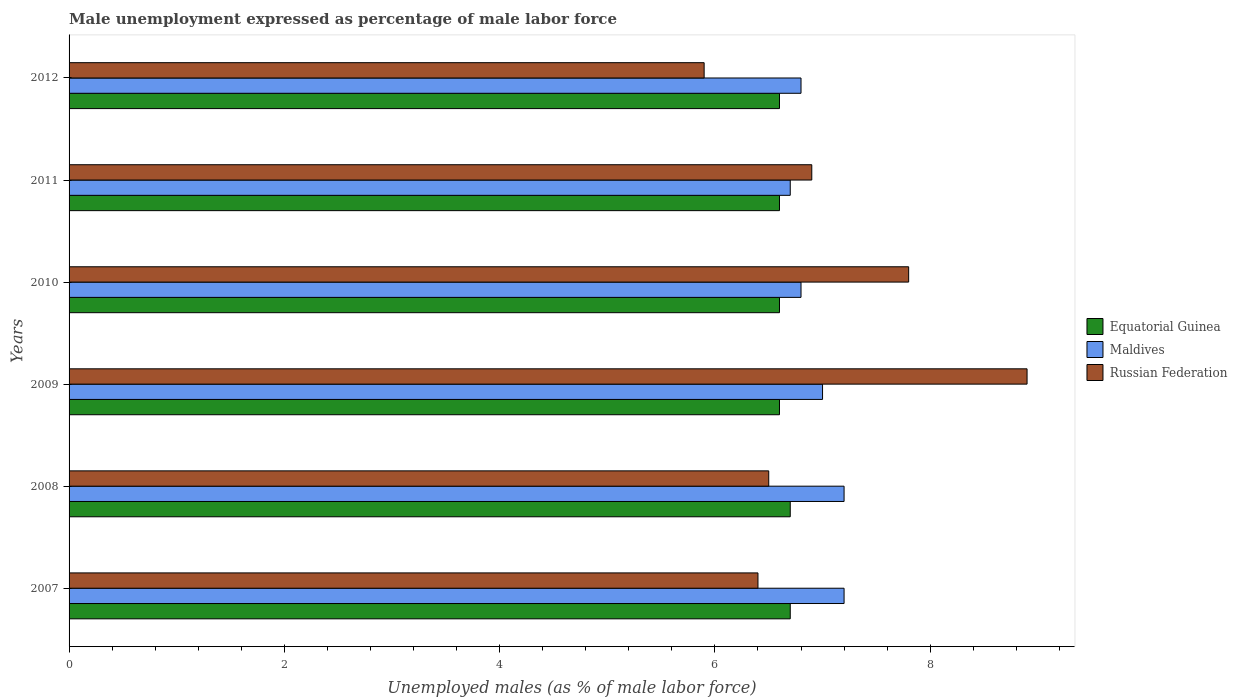How many different coloured bars are there?
Ensure brevity in your answer.  3. How many groups of bars are there?
Your answer should be compact. 6. Are the number of bars per tick equal to the number of legend labels?
Offer a very short reply. Yes. Are the number of bars on each tick of the Y-axis equal?
Give a very brief answer. Yes. How many bars are there on the 1st tick from the bottom?
Give a very brief answer. 3. What is the label of the 5th group of bars from the top?
Provide a succinct answer. 2008. In how many cases, is the number of bars for a given year not equal to the number of legend labels?
Keep it short and to the point. 0. What is the unemployment in males in in Equatorial Guinea in 2007?
Ensure brevity in your answer.  6.7. Across all years, what is the maximum unemployment in males in in Equatorial Guinea?
Offer a terse response. 6.7. Across all years, what is the minimum unemployment in males in in Equatorial Guinea?
Your answer should be compact. 6.6. In which year was the unemployment in males in in Russian Federation minimum?
Your answer should be compact. 2012. What is the total unemployment in males in in Equatorial Guinea in the graph?
Your response must be concise. 39.8. What is the difference between the unemployment in males in in Equatorial Guinea in 2010 and that in 2011?
Offer a very short reply. 0. What is the difference between the unemployment in males in in Russian Federation in 2009 and the unemployment in males in in Maldives in 2012?
Make the answer very short. 2.1. What is the average unemployment in males in in Russian Federation per year?
Your answer should be compact. 7.07. In the year 2008, what is the difference between the unemployment in males in in Russian Federation and unemployment in males in in Equatorial Guinea?
Offer a very short reply. -0.2. In how many years, is the unemployment in males in in Russian Federation greater than 2.8 %?
Make the answer very short. 6. What is the ratio of the unemployment in males in in Equatorial Guinea in 2007 to that in 2012?
Offer a very short reply. 1.02. Is the unemployment in males in in Russian Federation in 2010 less than that in 2012?
Offer a terse response. No. What is the difference between the highest and the lowest unemployment in males in in Russian Federation?
Give a very brief answer. 3. In how many years, is the unemployment in males in in Russian Federation greater than the average unemployment in males in in Russian Federation taken over all years?
Your answer should be compact. 2. What does the 3rd bar from the top in 2010 represents?
Make the answer very short. Equatorial Guinea. What does the 2nd bar from the bottom in 2011 represents?
Provide a short and direct response. Maldives. Is it the case that in every year, the sum of the unemployment in males in in Russian Federation and unemployment in males in in Maldives is greater than the unemployment in males in in Equatorial Guinea?
Your answer should be compact. Yes. How many bars are there?
Offer a terse response. 18. What is the difference between two consecutive major ticks on the X-axis?
Keep it short and to the point. 2. Are the values on the major ticks of X-axis written in scientific E-notation?
Your response must be concise. No. Does the graph contain grids?
Offer a very short reply. No. How many legend labels are there?
Make the answer very short. 3. How are the legend labels stacked?
Keep it short and to the point. Vertical. What is the title of the graph?
Your response must be concise. Male unemployment expressed as percentage of male labor force. What is the label or title of the X-axis?
Make the answer very short. Unemployed males (as % of male labor force). What is the Unemployed males (as % of male labor force) in Equatorial Guinea in 2007?
Your answer should be very brief. 6.7. What is the Unemployed males (as % of male labor force) of Maldives in 2007?
Keep it short and to the point. 7.2. What is the Unemployed males (as % of male labor force) in Russian Federation in 2007?
Offer a very short reply. 6.4. What is the Unemployed males (as % of male labor force) in Equatorial Guinea in 2008?
Ensure brevity in your answer.  6.7. What is the Unemployed males (as % of male labor force) of Maldives in 2008?
Provide a short and direct response. 7.2. What is the Unemployed males (as % of male labor force) of Equatorial Guinea in 2009?
Ensure brevity in your answer.  6.6. What is the Unemployed males (as % of male labor force) in Russian Federation in 2009?
Offer a very short reply. 8.9. What is the Unemployed males (as % of male labor force) of Equatorial Guinea in 2010?
Ensure brevity in your answer.  6.6. What is the Unemployed males (as % of male labor force) in Maldives in 2010?
Ensure brevity in your answer.  6.8. What is the Unemployed males (as % of male labor force) of Russian Federation in 2010?
Provide a succinct answer. 7.8. What is the Unemployed males (as % of male labor force) in Equatorial Guinea in 2011?
Provide a short and direct response. 6.6. What is the Unemployed males (as % of male labor force) in Maldives in 2011?
Offer a very short reply. 6.7. What is the Unemployed males (as % of male labor force) in Russian Federation in 2011?
Provide a succinct answer. 6.9. What is the Unemployed males (as % of male labor force) of Equatorial Guinea in 2012?
Provide a short and direct response. 6.6. What is the Unemployed males (as % of male labor force) in Maldives in 2012?
Ensure brevity in your answer.  6.8. What is the Unemployed males (as % of male labor force) in Russian Federation in 2012?
Provide a succinct answer. 5.9. Across all years, what is the maximum Unemployed males (as % of male labor force) in Equatorial Guinea?
Ensure brevity in your answer.  6.7. Across all years, what is the maximum Unemployed males (as % of male labor force) of Maldives?
Your response must be concise. 7.2. Across all years, what is the maximum Unemployed males (as % of male labor force) in Russian Federation?
Ensure brevity in your answer.  8.9. Across all years, what is the minimum Unemployed males (as % of male labor force) of Equatorial Guinea?
Provide a short and direct response. 6.6. Across all years, what is the minimum Unemployed males (as % of male labor force) of Maldives?
Provide a short and direct response. 6.7. Across all years, what is the minimum Unemployed males (as % of male labor force) in Russian Federation?
Make the answer very short. 5.9. What is the total Unemployed males (as % of male labor force) in Equatorial Guinea in the graph?
Your answer should be compact. 39.8. What is the total Unemployed males (as % of male labor force) of Maldives in the graph?
Provide a short and direct response. 41.7. What is the total Unemployed males (as % of male labor force) of Russian Federation in the graph?
Your answer should be compact. 42.4. What is the difference between the Unemployed males (as % of male labor force) in Maldives in 2007 and that in 2008?
Give a very brief answer. 0. What is the difference between the Unemployed males (as % of male labor force) in Russian Federation in 2007 and that in 2008?
Ensure brevity in your answer.  -0.1. What is the difference between the Unemployed males (as % of male labor force) of Equatorial Guinea in 2007 and that in 2009?
Your answer should be compact. 0.1. What is the difference between the Unemployed males (as % of male labor force) of Maldives in 2007 and that in 2009?
Keep it short and to the point. 0.2. What is the difference between the Unemployed males (as % of male labor force) in Russian Federation in 2007 and that in 2009?
Offer a terse response. -2.5. What is the difference between the Unemployed males (as % of male labor force) of Equatorial Guinea in 2007 and that in 2010?
Provide a succinct answer. 0.1. What is the difference between the Unemployed males (as % of male labor force) in Maldives in 2007 and that in 2010?
Keep it short and to the point. 0.4. What is the difference between the Unemployed males (as % of male labor force) in Russian Federation in 2007 and that in 2010?
Offer a very short reply. -1.4. What is the difference between the Unemployed males (as % of male labor force) of Equatorial Guinea in 2007 and that in 2011?
Your response must be concise. 0.1. What is the difference between the Unemployed males (as % of male labor force) in Maldives in 2007 and that in 2011?
Provide a succinct answer. 0.5. What is the difference between the Unemployed males (as % of male labor force) in Russian Federation in 2007 and that in 2011?
Keep it short and to the point. -0.5. What is the difference between the Unemployed males (as % of male labor force) in Equatorial Guinea in 2007 and that in 2012?
Provide a short and direct response. 0.1. What is the difference between the Unemployed males (as % of male labor force) of Russian Federation in 2007 and that in 2012?
Provide a short and direct response. 0.5. What is the difference between the Unemployed males (as % of male labor force) in Maldives in 2008 and that in 2009?
Your answer should be compact. 0.2. What is the difference between the Unemployed males (as % of male labor force) of Equatorial Guinea in 2008 and that in 2010?
Make the answer very short. 0.1. What is the difference between the Unemployed males (as % of male labor force) of Maldives in 2008 and that in 2010?
Offer a very short reply. 0.4. What is the difference between the Unemployed males (as % of male labor force) in Russian Federation in 2008 and that in 2010?
Provide a succinct answer. -1.3. What is the difference between the Unemployed males (as % of male labor force) of Equatorial Guinea in 2008 and that in 2011?
Keep it short and to the point. 0.1. What is the difference between the Unemployed males (as % of male labor force) of Equatorial Guinea in 2008 and that in 2012?
Offer a terse response. 0.1. What is the difference between the Unemployed males (as % of male labor force) of Russian Federation in 2008 and that in 2012?
Provide a succinct answer. 0.6. What is the difference between the Unemployed males (as % of male labor force) of Equatorial Guinea in 2009 and that in 2010?
Your answer should be compact. 0. What is the difference between the Unemployed males (as % of male labor force) in Maldives in 2009 and that in 2011?
Offer a terse response. 0.3. What is the difference between the Unemployed males (as % of male labor force) in Equatorial Guinea in 2009 and that in 2012?
Provide a short and direct response. 0. What is the difference between the Unemployed males (as % of male labor force) in Equatorial Guinea in 2010 and that in 2011?
Make the answer very short. 0. What is the difference between the Unemployed males (as % of male labor force) of Maldives in 2011 and that in 2012?
Give a very brief answer. -0.1. What is the difference between the Unemployed males (as % of male labor force) in Russian Federation in 2011 and that in 2012?
Give a very brief answer. 1. What is the difference between the Unemployed males (as % of male labor force) of Maldives in 2007 and the Unemployed males (as % of male labor force) of Russian Federation in 2008?
Provide a short and direct response. 0.7. What is the difference between the Unemployed males (as % of male labor force) in Equatorial Guinea in 2007 and the Unemployed males (as % of male labor force) in Maldives in 2010?
Offer a terse response. -0.1. What is the difference between the Unemployed males (as % of male labor force) in Maldives in 2007 and the Unemployed males (as % of male labor force) in Russian Federation in 2010?
Offer a terse response. -0.6. What is the difference between the Unemployed males (as % of male labor force) of Equatorial Guinea in 2007 and the Unemployed males (as % of male labor force) of Maldives in 2011?
Your response must be concise. 0. What is the difference between the Unemployed males (as % of male labor force) of Equatorial Guinea in 2007 and the Unemployed males (as % of male labor force) of Russian Federation in 2011?
Offer a terse response. -0.2. What is the difference between the Unemployed males (as % of male labor force) in Equatorial Guinea in 2007 and the Unemployed males (as % of male labor force) in Maldives in 2012?
Make the answer very short. -0.1. What is the difference between the Unemployed males (as % of male labor force) in Equatorial Guinea in 2007 and the Unemployed males (as % of male labor force) in Russian Federation in 2012?
Offer a terse response. 0.8. What is the difference between the Unemployed males (as % of male labor force) in Maldives in 2007 and the Unemployed males (as % of male labor force) in Russian Federation in 2012?
Give a very brief answer. 1.3. What is the difference between the Unemployed males (as % of male labor force) in Equatorial Guinea in 2008 and the Unemployed males (as % of male labor force) in Russian Federation in 2009?
Offer a terse response. -2.2. What is the difference between the Unemployed males (as % of male labor force) of Equatorial Guinea in 2008 and the Unemployed males (as % of male labor force) of Maldives in 2010?
Make the answer very short. -0.1. What is the difference between the Unemployed males (as % of male labor force) in Equatorial Guinea in 2008 and the Unemployed males (as % of male labor force) in Maldives in 2011?
Keep it short and to the point. 0. What is the difference between the Unemployed males (as % of male labor force) in Equatorial Guinea in 2008 and the Unemployed males (as % of male labor force) in Russian Federation in 2011?
Make the answer very short. -0.2. What is the difference between the Unemployed males (as % of male labor force) of Equatorial Guinea in 2008 and the Unemployed males (as % of male labor force) of Maldives in 2012?
Make the answer very short. -0.1. What is the difference between the Unemployed males (as % of male labor force) of Equatorial Guinea in 2008 and the Unemployed males (as % of male labor force) of Russian Federation in 2012?
Offer a terse response. 0.8. What is the difference between the Unemployed males (as % of male labor force) of Equatorial Guinea in 2009 and the Unemployed males (as % of male labor force) of Maldives in 2010?
Your answer should be compact. -0.2. What is the difference between the Unemployed males (as % of male labor force) of Maldives in 2009 and the Unemployed males (as % of male labor force) of Russian Federation in 2010?
Offer a very short reply. -0.8. What is the difference between the Unemployed males (as % of male labor force) in Equatorial Guinea in 2009 and the Unemployed males (as % of male labor force) in Maldives in 2011?
Your answer should be compact. -0.1. What is the difference between the Unemployed males (as % of male labor force) in Maldives in 2009 and the Unemployed males (as % of male labor force) in Russian Federation in 2011?
Your answer should be compact. 0.1. What is the difference between the Unemployed males (as % of male labor force) in Equatorial Guinea in 2009 and the Unemployed males (as % of male labor force) in Maldives in 2012?
Provide a succinct answer. -0.2. What is the difference between the Unemployed males (as % of male labor force) in Equatorial Guinea in 2010 and the Unemployed males (as % of male labor force) in Maldives in 2011?
Keep it short and to the point. -0.1. What is the difference between the Unemployed males (as % of male labor force) in Equatorial Guinea in 2010 and the Unemployed males (as % of male labor force) in Maldives in 2012?
Your response must be concise. -0.2. What is the difference between the Unemployed males (as % of male labor force) of Maldives in 2010 and the Unemployed males (as % of male labor force) of Russian Federation in 2012?
Offer a terse response. 0.9. What is the average Unemployed males (as % of male labor force) of Equatorial Guinea per year?
Provide a succinct answer. 6.63. What is the average Unemployed males (as % of male labor force) of Maldives per year?
Your answer should be compact. 6.95. What is the average Unemployed males (as % of male labor force) of Russian Federation per year?
Offer a terse response. 7.07. In the year 2007, what is the difference between the Unemployed males (as % of male labor force) in Equatorial Guinea and Unemployed males (as % of male labor force) in Maldives?
Provide a succinct answer. -0.5. In the year 2007, what is the difference between the Unemployed males (as % of male labor force) of Equatorial Guinea and Unemployed males (as % of male labor force) of Russian Federation?
Offer a very short reply. 0.3. In the year 2008, what is the difference between the Unemployed males (as % of male labor force) of Equatorial Guinea and Unemployed males (as % of male labor force) of Maldives?
Ensure brevity in your answer.  -0.5. In the year 2008, what is the difference between the Unemployed males (as % of male labor force) of Maldives and Unemployed males (as % of male labor force) of Russian Federation?
Offer a very short reply. 0.7. In the year 2009, what is the difference between the Unemployed males (as % of male labor force) of Equatorial Guinea and Unemployed males (as % of male labor force) of Maldives?
Keep it short and to the point. -0.4. In the year 2009, what is the difference between the Unemployed males (as % of male labor force) of Equatorial Guinea and Unemployed males (as % of male labor force) of Russian Federation?
Keep it short and to the point. -2.3. In the year 2011, what is the difference between the Unemployed males (as % of male labor force) of Equatorial Guinea and Unemployed males (as % of male labor force) of Russian Federation?
Your answer should be compact. -0.3. In the year 2011, what is the difference between the Unemployed males (as % of male labor force) in Maldives and Unemployed males (as % of male labor force) in Russian Federation?
Provide a short and direct response. -0.2. In the year 2012, what is the difference between the Unemployed males (as % of male labor force) of Equatorial Guinea and Unemployed males (as % of male labor force) of Maldives?
Your answer should be very brief. -0.2. In the year 2012, what is the difference between the Unemployed males (as % of male labor force) of Equatorial Guinea and Unemployed males (as % of male labor force) of Russian Federation?
Make the answer very short. 0.7. What is the ratio of the Unemployed males (as % of male labor force) of Equatorial Guinea in 2007 to that in 2008?
Give a very brief answer. 1. What is the ratio of the Unemployed males (as % of male labor force) of Maldives in 2007 to that in 2008?
Give a very brief answer. 1. What is the ratio of the Unemployed males (as % of male labor force) of Russian Federation in 2007 to that in 2008?
Ensure brevity in your answer.  0.98. What is the ratio of the Unemployed males (as % of male labor force) of Equatorial Guinea in 2007 to that in 2009?
Your answer should be very brief. 1.02. What is the ratio of the Unemployed males (as % of male labor force) in Maldives in 2007 to that in 2009?
Provide a succinct answer. 1.03. What is the ratio of the Unemployed males (as % of male labor force) of Russian Federation in 2007 to that in 2009?
Your answer should be compact. 0.72. What is the ratio of the Unemployed males (as % of male labor force) of Equatorial Guinea in 2007 to that in 2010?
Offer a very short reply. 1.02. What is the ratio of the Unemployed males (as % of male labor force) in Maldives in 2007 to that in 2010?
Offer a very short reply. 1.06. What is the ratio of the Unemployed males (as % of male labor force) in Russian Federation in 2007 to that in 2010?
Your answer should be very brief. 0.82. What is the ratio of the Unemployed males (as % of male labor force) of Equatorial Guinea in 2007 to that in 2011?
Ensure brevity in your answer.  1.02. What is the ratio of the Unemployed males (as % of male labor force) of Maldives in 2007 to that in 2011?
Your answer should be compact. 1.07. What is the ratio of the Unemployed males (as % of male labor force) in Russian Federation in 2007 to that in 2011?
Provide a short and direct response. 0.93. What is the ratio of the Unemployed males (as % of male labor force) of Equatorial Guinea in 2007 to that in 2012?
Provide a short and direct response. 1.02. What is the ratio of the Unemployed males (as % of male labor force) in Maldives in 2007 to that in 2012?
Provide a short and direct response. 1.06. What is the ratio of the Unemployed males (as % of male labor force) of Russian Federation in 2007 to that in 2012?
Your response must be concise. 1.08. What is the ratio of the Unemployed males (as % of male labor force) in Equatorial Guinea in 2008 to that in 2009?
Your response must be concise. 1.02. What is the ratio of the Unemployed males (as % of male labor force) of Maldives in 2008 to that in 2009?
Ensure brevity in your answer.  1.03. What is the ratio of the Unemployed males (as % of male labor force) in Russian Federation in 2008 to that in 2009?
Make the answer very short. 0.73. What is the ratio of the Unemployed males (as % of male labor force) in Equatorial Guinea in 2008 to that in 2010?
Your answer should be compact. 1.02. What is the ratio of the Unemployed males (as % of male labor force) of Maldives in 2008 to that in 2010?
Provide a short and direct response. 1.06. What is the ratio of the Unemployed males (as % of male labor force) in Russian Federation in 2008 to that in 2010?
Provide a succinct answer. 0.83. What is the ratio of the Unemployed males (as % of male labor force) of Equatorial Guinea in 2008 to that in 2011?
Provide a succinct answer. 1.02. What is the ratio of the Unemployed males (as % of male labor force) of Maldives in 2008 to that in 2011?
Your answer should be very brief. 1.07. What is the ratio of the Unemployed males (as % of male labor force) of Russian Federation in 2008 to that in 2011?
Your answer should be compact. 0.94. What is the ratio of the Unemployed males (as % of male labor force) in Equatorial Guinea in 2008 to that in 2012?
Your answer should be compact. 1.02. What is the ratio of the Unemployed males (as % of male labor force) of Maldives in 2008 to that in 2012?
Your answer should be very brief. 1.06. What is the ratio of the Unemployed males (as % of male labor force) in Russian Federation in 2008 to that in 2012?
Ensure brevity in your answer.  1.1. What is the ratio of the Unemployed males (as % of male labor force) of Maldives in 2009 to that in 2010?
Keep it short and to the point. 1.03. What is the ratio of the Unemployed males (as % of male labor force) in Russian Federation in 2009 to that in 2010?
Your answer should be very brief. 1.14. What is the ratio of the Unemployed males (as % of male labor force) of Maldives in 2009 to that in 2011?
Your answer should be compact. 1.04. What is the ratio of the Unemployed males (as % of male labor force) of Russian Federation in 2009 to that in 2011?
Provide a short and direct response. 1.29. What is the ratio of the Unemployed males (as % of male labor force) in Maldives in 2009 to that in 2012?
Your response must be concise. 1.03. What is the ratio of the Unemployed males (as % of male labor force) in Russian Federation in 2009 to that in 2012?
Your answer should be very brief. 1.51. What is the ratio of the Unemployed males (as % of male labor force) in Maldives in 2010 to that in 2011?
Your answer should be compact. 1.01. What is the ratio of the Unemployed males (as % of male labor force) in Russian Federation in 2010 to that in 2011?
Your answer should be compact. 1.13. What is the ratio of the Unemployed males (as % of male labor force) in Equatorial Guinea in 2010 to that in 2012?
Ensure brevity in your answer.  1. What is the ratio of the Unemployed males (as % of male labor force) in Russian Federation in 2010 to that in 2012?
Offer a very short reply. 1.32. What is the ratio of the Unemployed males (as % of male labor force) of Equatorial Guinea in 2011 to that in 2012?
Give a very brief answer. 1. What is the ratio of the Unemployed males (as % of male labor force) in Russian Federation in 2011 to that in 2012?
Keep it short and to the point. 1.17. What is the difference between the highest and the second highest Unemployed males (as % of male labor force) in Maldives?
Offer a very short reply. 0. What is the difference between the highest and the second highest Unemployed males (as % of male labor force) of Russian Federation?
Give a very brief answer. 1.1. What is the difference between the highest and the lowest Unemployed males (as % of male labor force) in Equatorial Guinea?
Your answer should be compact. 0.1. What is the difference between the highest and the lowest Unemployed males (as % of male labor force) in Russian Federation?
Your answer should be very brief. 3. 